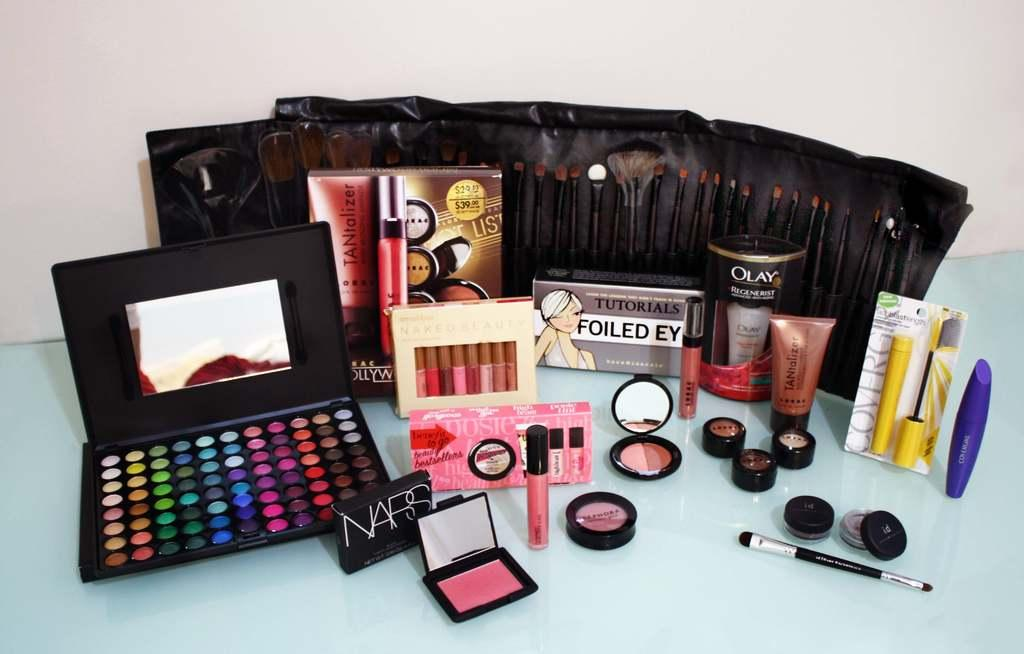<image>
Relay a brief, clear account of the picture shown. A large collection of make up including NARS. 